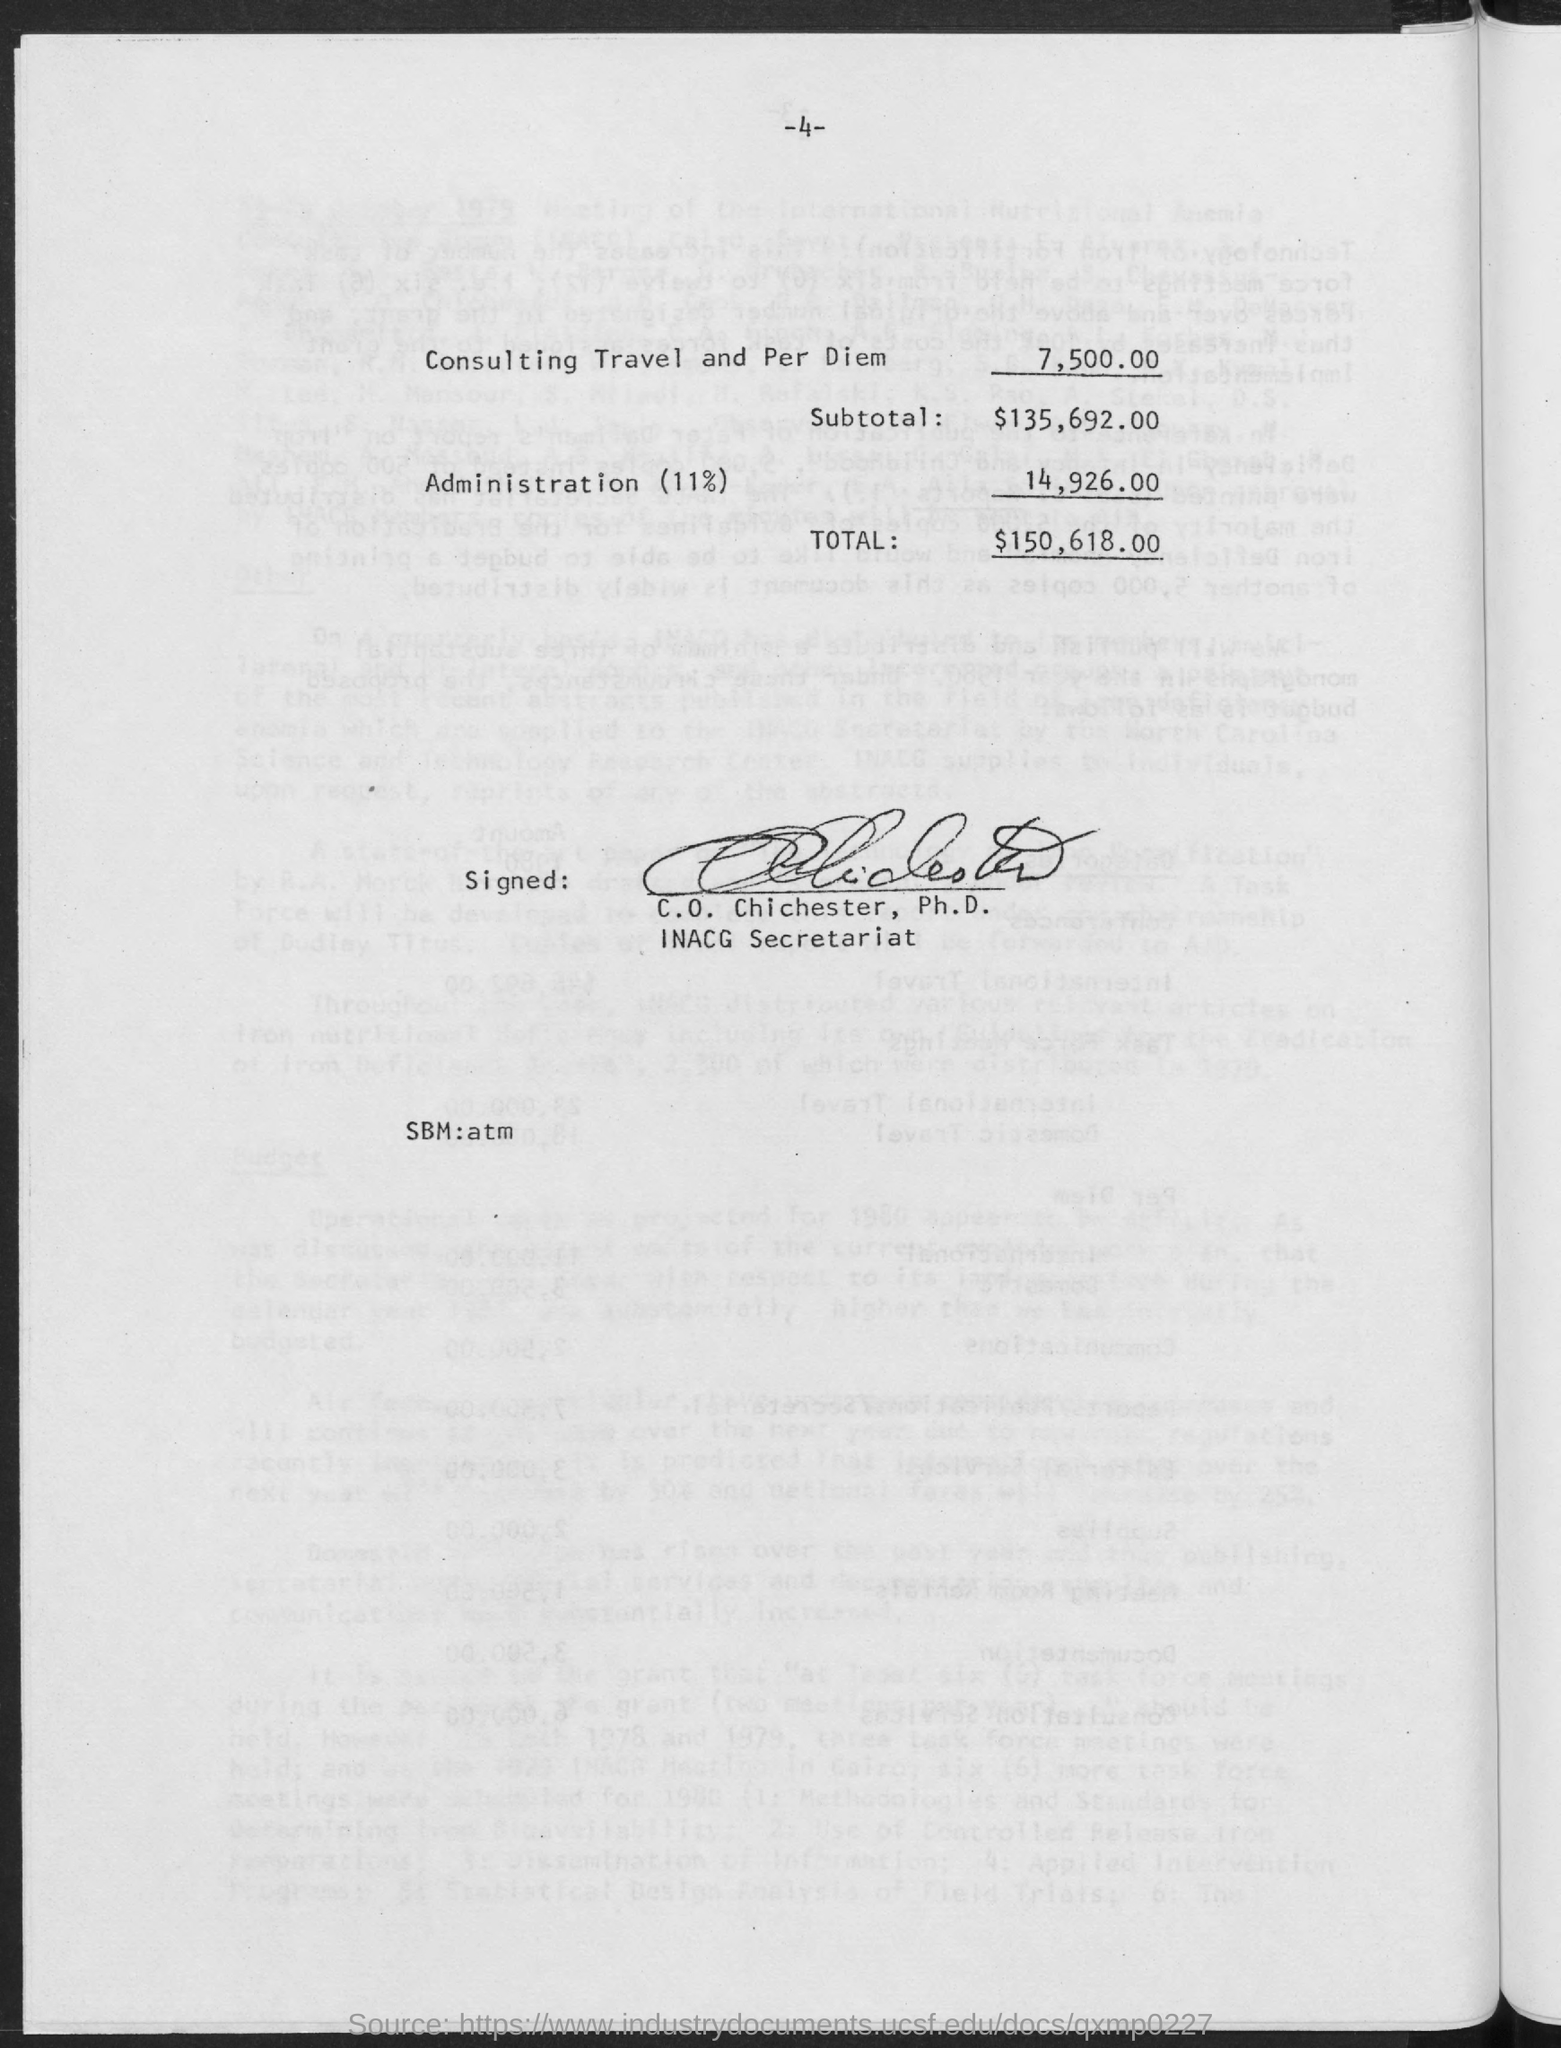Indicate a few pertinent items in this graphic. The administration cost is 14,926.00. The signature on the document reads, 'Who is it signed by? C. O. Chichester, Ph.D...' The subtotal is $135,692.00. Consulting travel and per diem is approximately $7,500. The total is $150,618.00. 